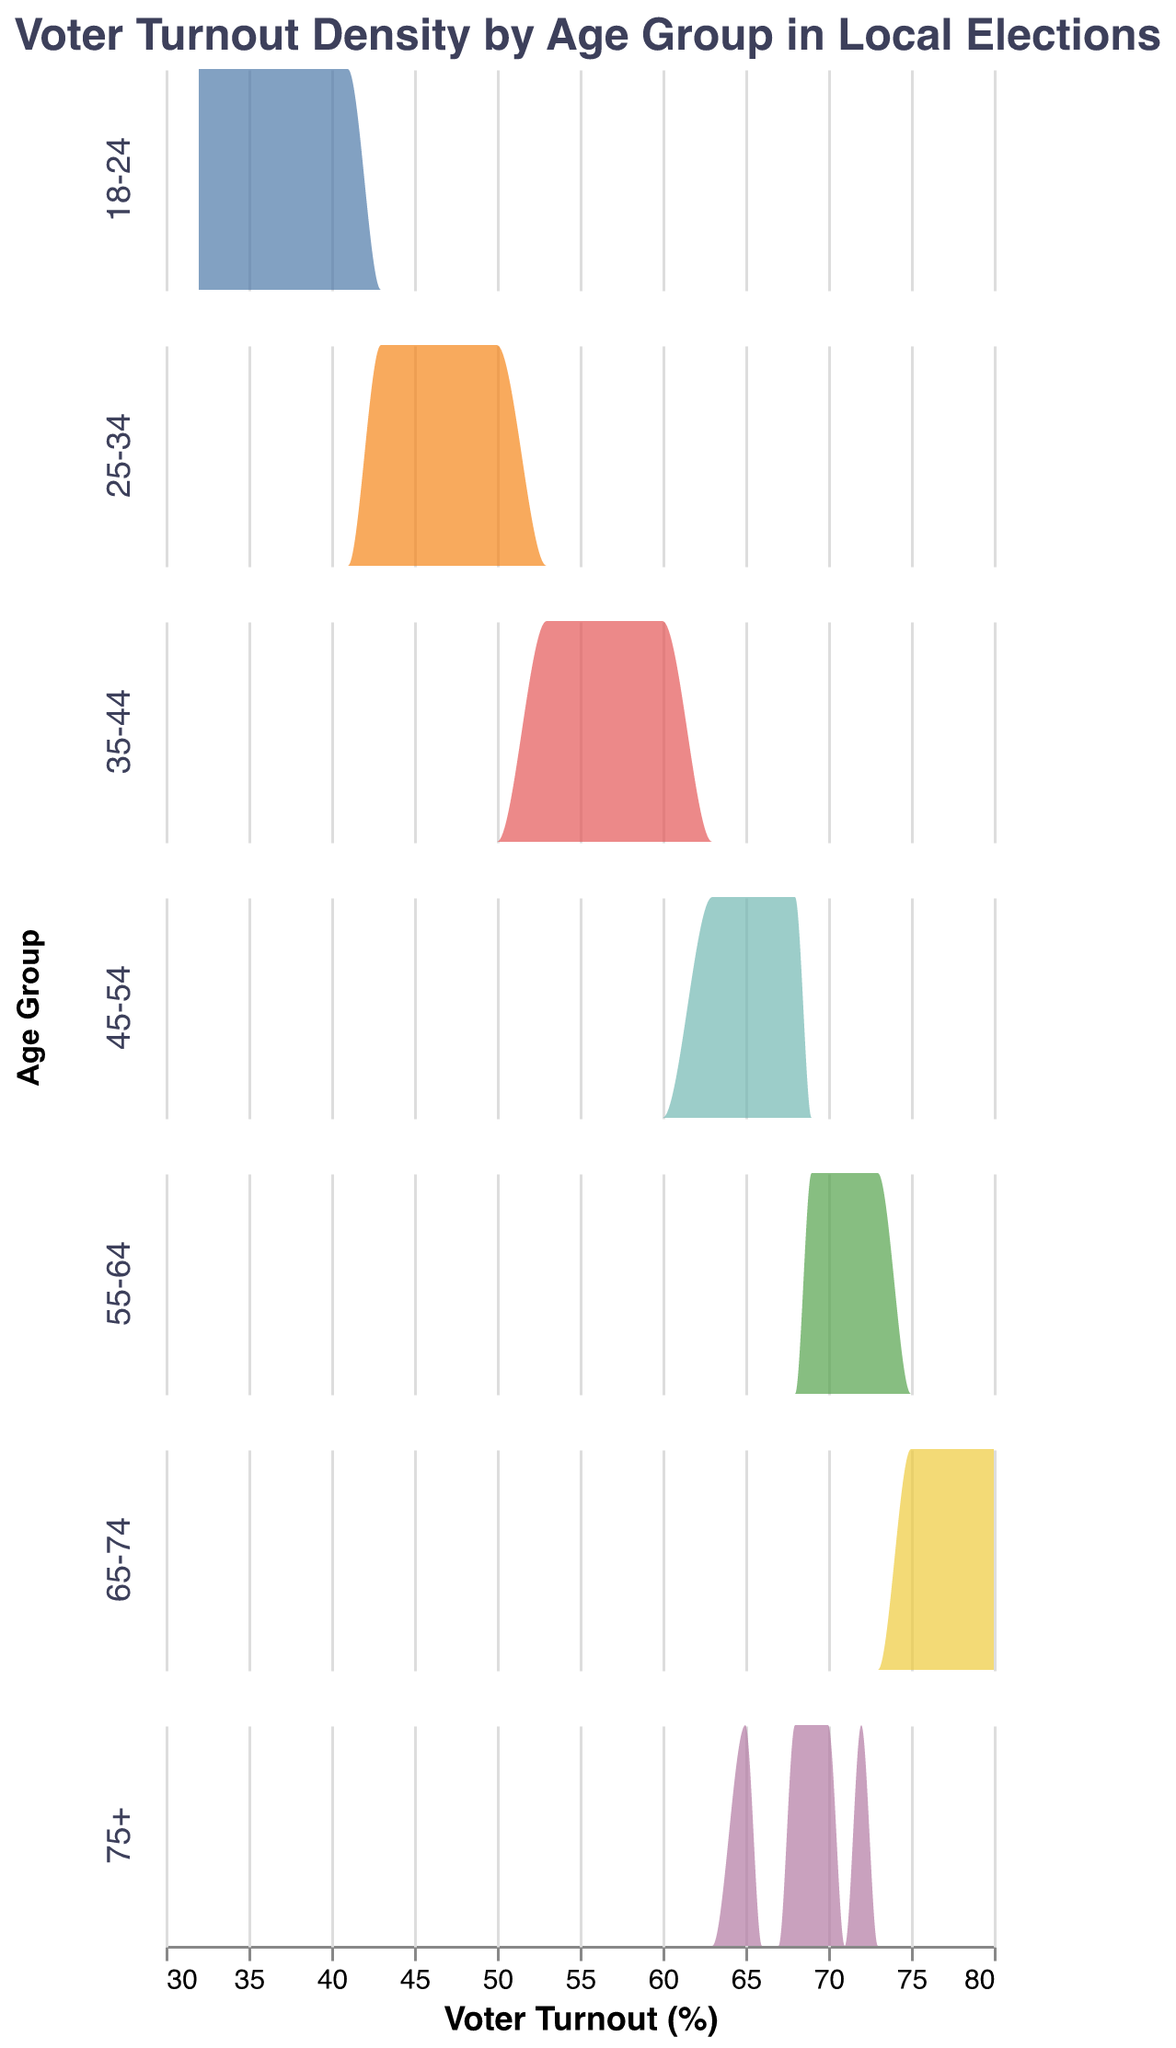What's the title of the plot? The title of the plot is located at the top of the figure, providing an overview of the visualized data. It reads "Voter Turnout Density by Age Group in Local Elections."
Answer: Voter Turnout Density by Age Group in Local Elections How many age groups are compared in the plot? By looking at the distinct rows in the subplot, each representing a different age group, we can count that there are six unique age groups.
Answer: Six Which age group has the highest voter turnout concentration? The density plots show the concentration of voter turnout for each age group. The age group "65-74" has the highest concentration, as it peaks around 78-80% turnout.
Answer: 65-74 What is the range of voter turnout percentages for the age group "25-34"? Evaluating the horizontal axis under the density plot for the "25-34" age group, the voter turnout percentages range from 43% to 50%.
Answer: 43-50% Is there any age group with voter turnout below 30%? By inspecting the x-axis for each age group's density plot, there are no values falling below 30% in any age group.
Answer: No How does the voter turnout for the "18-24" age group compare to the "45-54" age group? Comparing the density plots for the two age groups, "45-54" consistently has higher voter turnout percentages (63-68%) compared to "18-24" (32-41%).
Answer: 45-54 has a higher turnout Which age group has the widest range of voter turnout percentages? Observing the width of each density plot on the x-axis, "75+" age group shows a wide range of voter turnout percentages, spanning from 65% to 72%.
Answer: 75+ What can you infer about the general pattern of voter turnout across different age groups? The density plots indicate increasing voter turnout percentages as age groups advance, peaking at "65-74," then showing a slight decrease in the "75+" group.
Answer: Generally increasing with age What percentage does the "55-64" age group voter turnout mostly cluster around? The density plot of the "55-64" age group peaks and clusters around the 70-73% voter turnout range.
Answer: 70-73% 